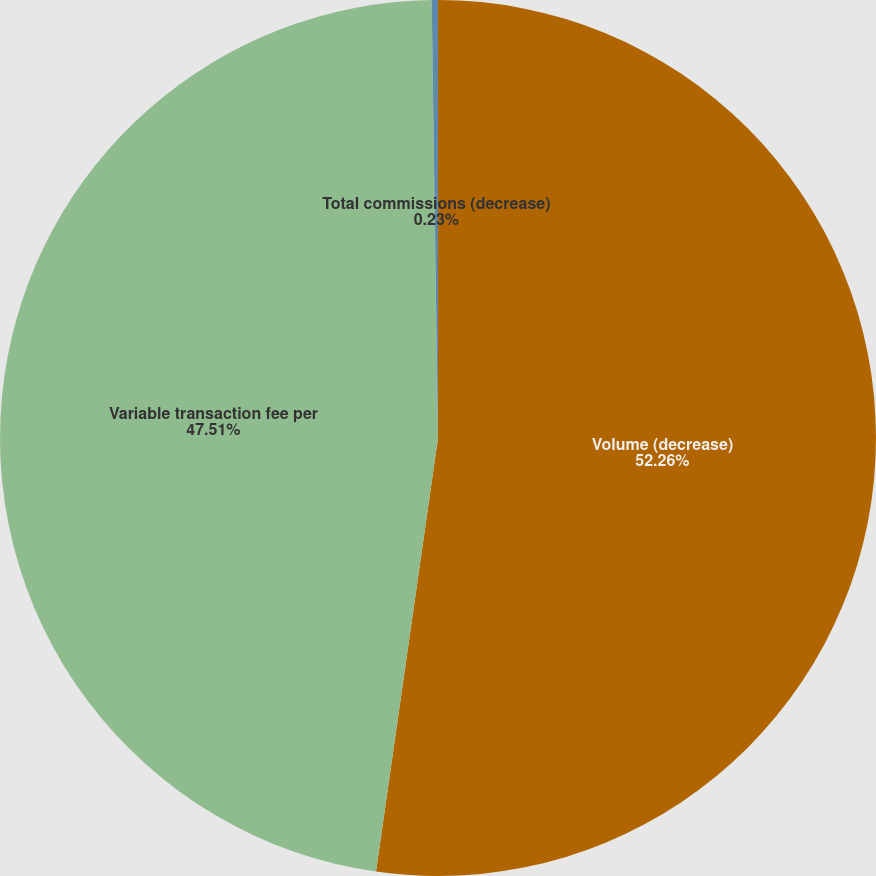Convert chart to OTSL. <chart><loc_0><loc_0><loc_500><loc_500><pie_chart><fcel>Volume (decrease)<fcel>Variable transaction fee per<fcel>Total commissions (decrease)<nl><fcel>52.26%<fcel>47.51%<fcel>0.23%<nl></chart> 